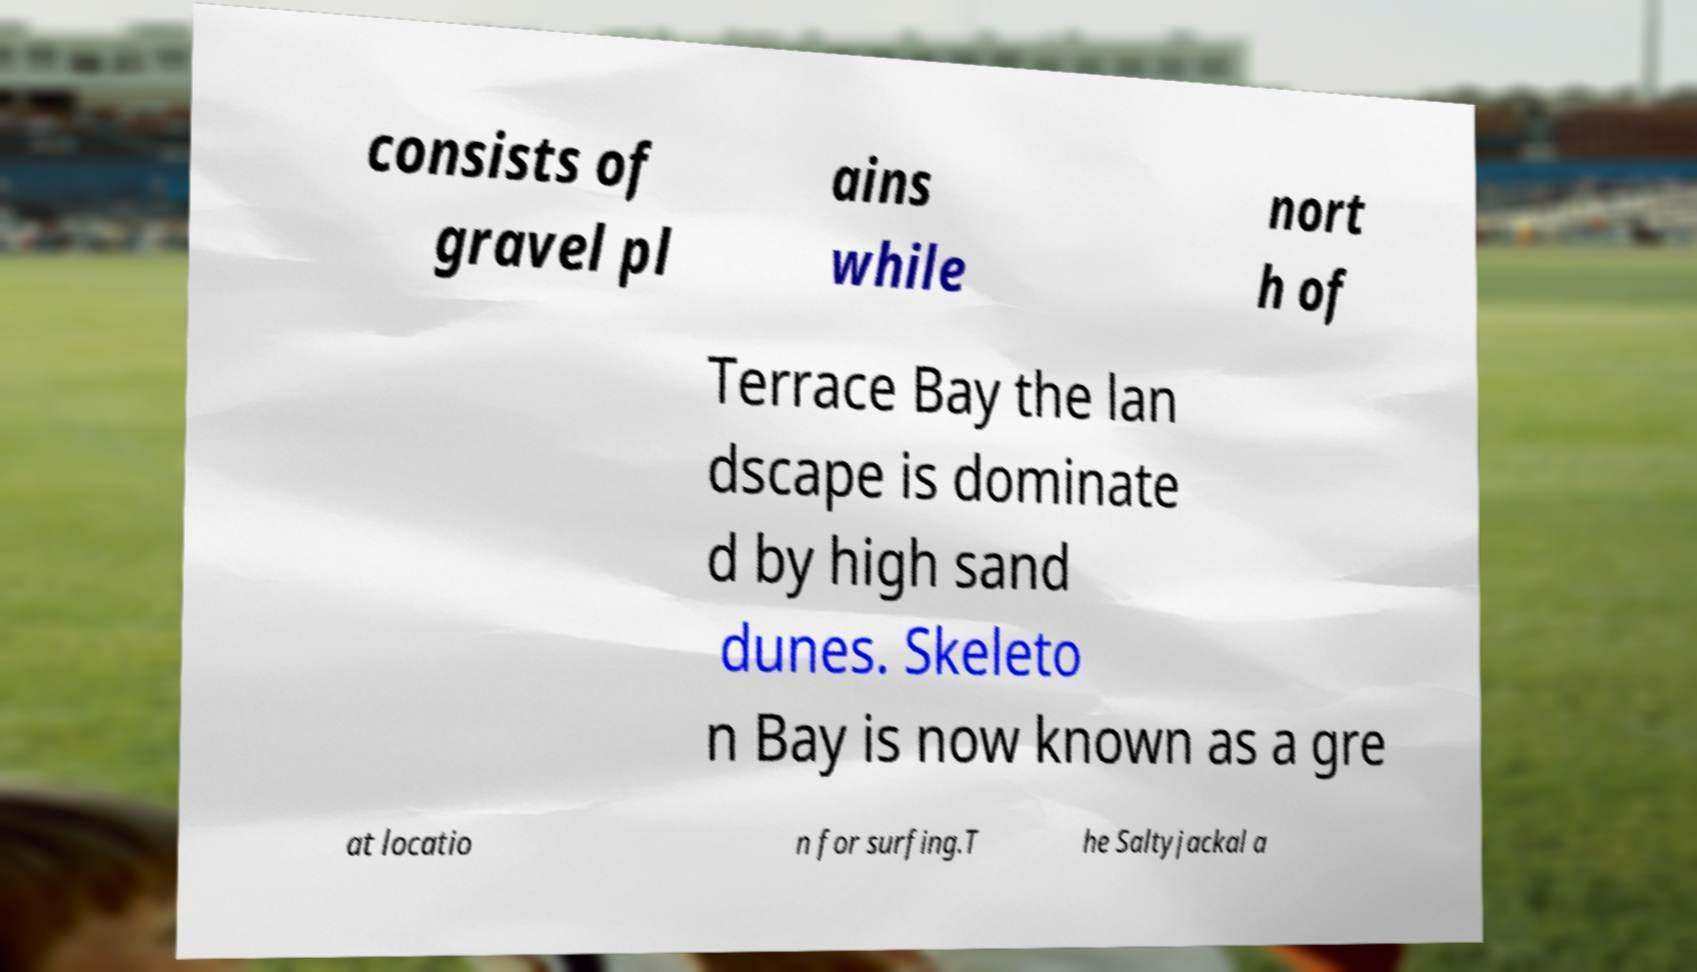Could you extract and type out the text from this image? consists of gravel pl ains while nort h of Terrace Bay the lan dscape is dominate d by high sand dunes. Skeleto n Bay is now known as a gre at locatio n for surfing.T he Saltyjackal a 